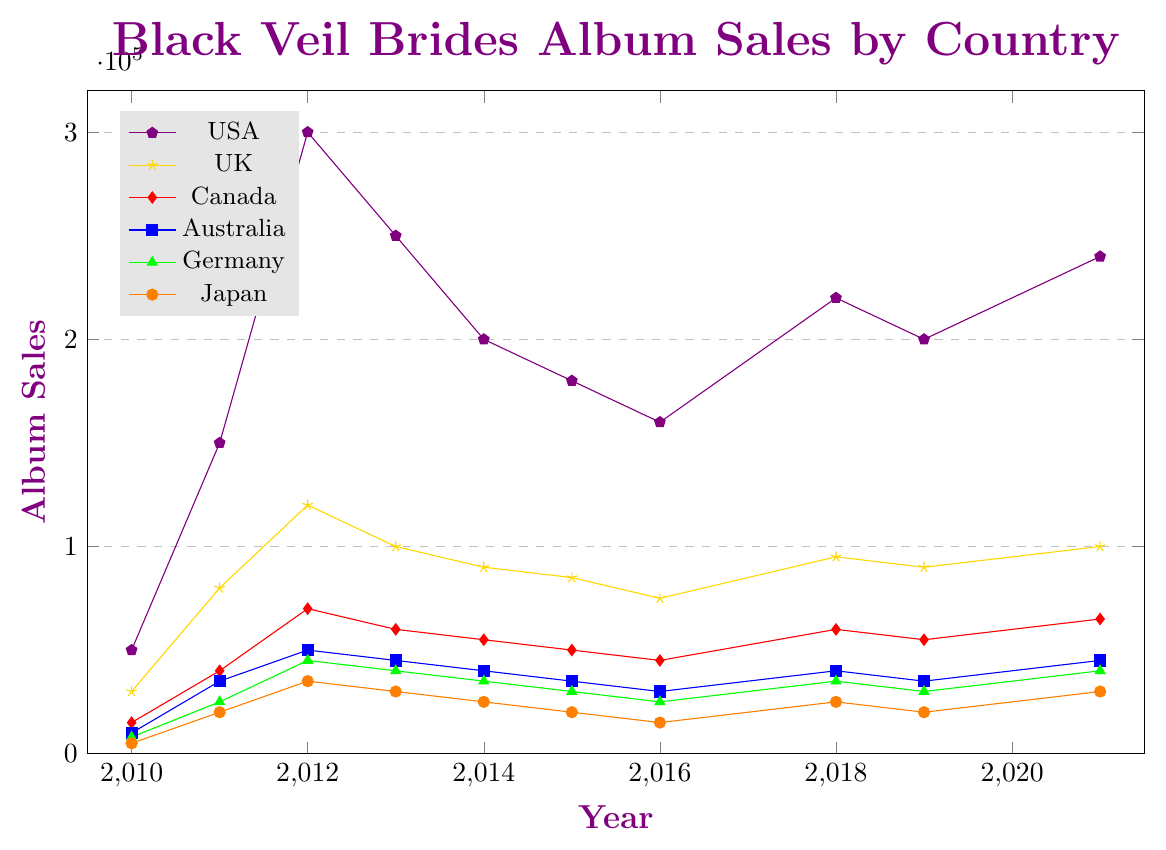Which country had the highest album sales in 2012? By looking at the highest points in the year 2012, we observe that the USA had the highest album sales.
Answer: USA How did the album sales in Germany change from 2010 to 2021? To answer this, we track the sales in Germany from 2010 to 2021. We notice that the sales increased from 8000 in 2010 to 40000 in 2021.
Answer: Increased What was the average album sales in Canada over all the recorded years? Calculate the total sales in Canada over all the years and divide by the number of years: (15000+40000+70000+60000+55000+50000+45000+60000+55000+65000)/10 = 52,500.
Answer: 52,500 Which year saw the lowest album sales in Japan, and what was the amount? By examining the graph, we find that the lowest point for Japan was in 2016, with 15000 sales.
Answer: 2016, 15000 Compare album sales in the UK and Australia in 2019. Which country had higher sales, and by how much? In 2019, the UK had 90000 sales, while Australia had 35000 sales. The UK had 55000 more sales than Australia.
Answer: UK, 55000 In which year did Australia achieve its peak album sales, and what was the figure? Identify the highest point on Australia's line, which occurred in 2012 with 50000 sales.
Answer: 2012, 50000 What is the difference in album sales between the highest sales year and the lowest sales year in the USA? The highest sales in the USA were in 2012 with 300000, and the lowest in 2010 with 50000. The difference is 300000 - 50000 = 250000.
Answer: 250000 What trend can be observed in Japan's album sales from 2010 to 2016? From 2010 to 2016, Japan's album sales showed a generally declining trend, decreasing from 5000 to 15000.
Answer: Declining Calculate the total album sales in the UK over the years 2018, 2019, and 2021 combined. Adding the sales for these years: 95000 (2018) + 90000 (2019) + 100000 (2021) = 285000.
Answer: 285000 Identify any countries where album sales fell consistently for at least three consecutive years. Germany's sales dropped consistently from 2012 to 2016 (45000 -> 40000 -> 35000 -> 30000 -> 25000).
Answer: Germany 